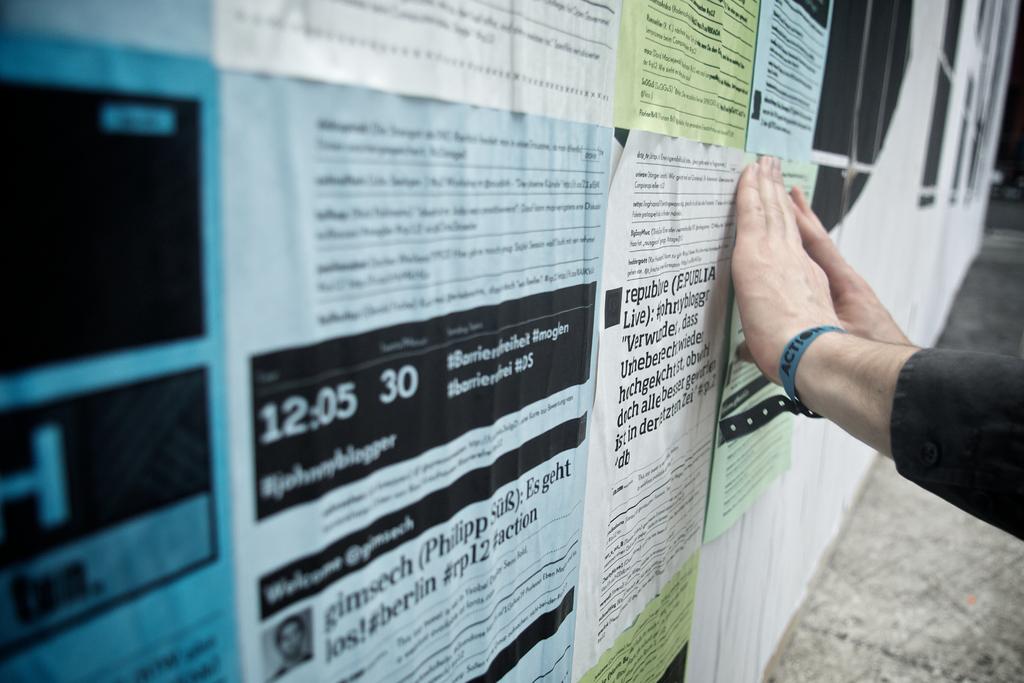What is the time on the flyer?
Your answer should be very brief. 12:05. 